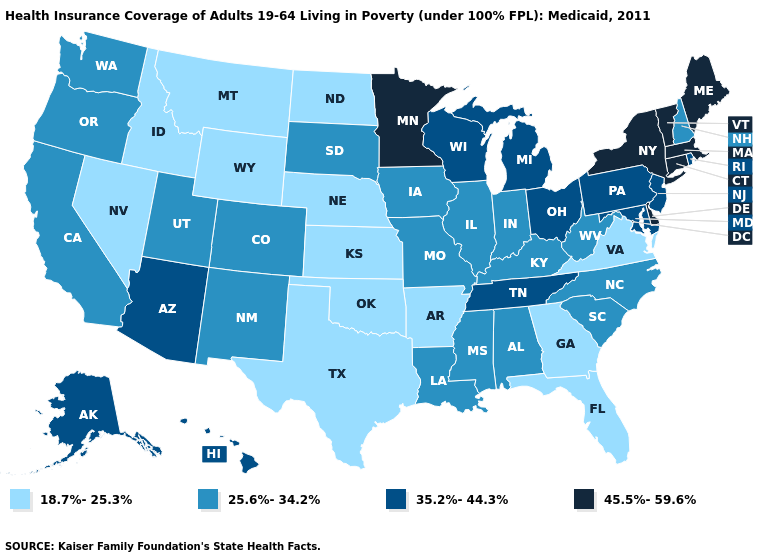Does Georgia have a lower value than Vermont?
Answer briefly. Yes. Does the first symbol in the legend represent the smallest category?
Answer briefly. Yes. What is the value of Michigan?
Answer briefly. 35.2%-44.3%. Among the states that border Utah , does Colorado have the lowest value?
Answer briefly. No. Among the states that border North Dakota , does South Dakota have the highest value?
Answer briefly. No. Does Wyoming have the lowest value in the USA?
Answer briefly. Yes. Name the states that have a value in the range 18.7%-25.3%?
Give a very brief answer. Arkansas, Florida, Georgia, Idaho, Kansas, Montana, Nebraska, Nevada, North Dakota, Oklahoma, Texas, Virginia, Wyoming. Does the first symbol in the legend represent the smallest category?
Concise answer only. Yes. What is the value of Kansas?
Short answer required. 18.7%-25.3%. Name the states that have a value in the range 35.2%-44.3%?
Short answer required. Alaska, Arizona, Hawaii, Maryland, Michigan, New Jersey, Ohio, Pennsylvania, Rhode Island, Tennessee, Wisconsin. Name the states that have a value in the range 25.6%-34.2%?
Write a very short answer. Alabama, California, Colorado, Illinois, Indiana, Iowa, Kentucky, Louisiana, Mississippi, Missouri, New Hampshire, New Mexico, North Carolina, Oregon, South Carolina, South Dakota, Utah, Washington, West Virginia. What is the lowest value in the South?
Be succinct. 18.7%-25.3%. What is the value of North Carolina?
Concise answer only. 25.6%-34.2%. Name the states that have a value in the range 35.2%-44.3%?
Quick response, please. Alaska, Arizona, Hawaii, Maryland, Michigan, New Jersey, Ohio, Pennsylvania, Rhode Island, Tennessee, Wisconsin. What is the lowest value in the South?
Give a very brief answer. 18.7%-25.3%. 